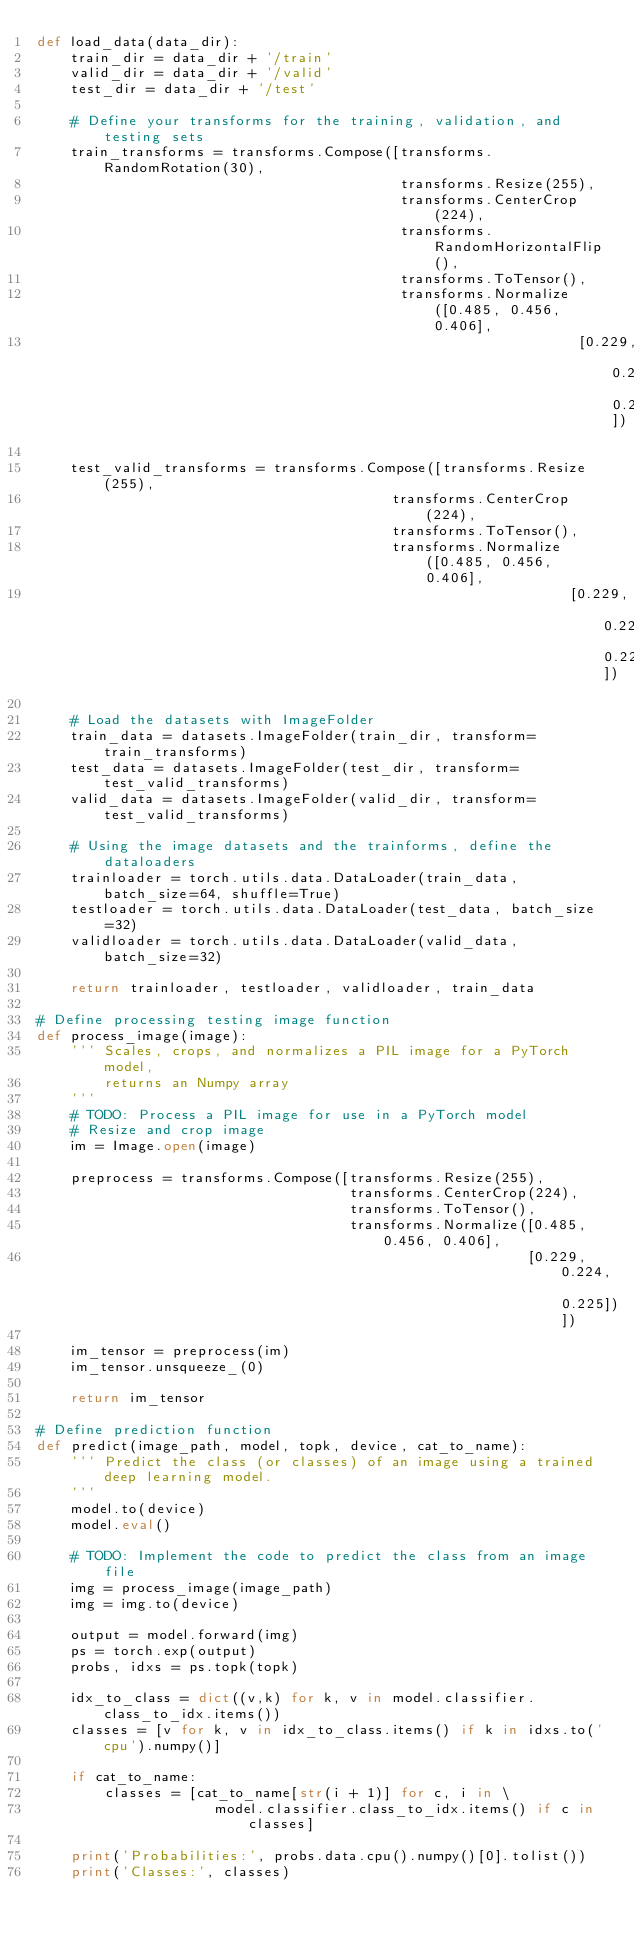<code> <loc_0><loc_0><loc_500><loc_500><_Python_>def load_data(data_dir):
    train_dir = data_dir + '/train'
    valid_dir = data_dir + '/valid'
    test_dir = data_dir + '/test'

    # Define your transforms for the training, validation, and testing sets
    train_transforms = transforms.Compose([transforms.RandomRotation(30),
                                           transforms.Resize(255),
                                           transforms.CenterCrop(224),
                                           transforms.RandomHorizontalFlip(),
                                           transforms.ToTensor(),
                                           transforms.Normalize([0.485, 0.456, 0.406],
                                                                [0.229, 0.224, 0.225])])

    test_valid_transforms = transforms.Compose([transforms.Resize(255), 
                                          transforms.CenterCrop(224),
                                          transforms.ToTensor(),
                                          transforms.Normalize([0.485, 0.456, 0.406],
                                                               [0.229, 0.224, 0.225])])

    # Load the datasets with ImageFolder
    train_data = datasets.ImageFolder(train_dir, transform=train_transforms)
    test_data = datasets.ImageFolder(test_dir, transform=test_valid_transforms)
    valid_data = datasets.ImageFolder(valid_dir, transform=test_valid_transforms)

    # Using the image datasets and the trainforms, define the dataloaders
    trainloader = torch.utils.data.DataLoader(train_data, batch_size=64, shuffle=True)
    testloader = torch.utils.data.DataLoader(test_data, batch_size=32)
    validloader = torch.utils.data.DataLoader(valid_data, batch_size=32)
    
    return trainloader, testloader, validloader, train_data

# Define processing testing image function
def process_image(image):
    ''' Scales, crops, and normalizes a PIL image for a PyTorch model,
        returns an Numpy array
    '''
    # TODO: Process a PIL image for use in a PyTorch model
    # Resize and crop image
    im = Image.open(image)
    
    preprocess = transforms.Compose([transforms.Resize(255), 
                                     transforms.CenterCrop(224),
                                     transforms.ToTensor(),
                                     transforms.Normalize([0.485, 0.456, 0.406],
                                                          [0.229, 0.224, 0.225])])
    
    im_tensor = preprocess(im)
    im_tensor.unsqueeze_(0)
    
    return im_tensor

# Define prediction function 
def predict(image_path, model, topk, device, cat_to_name):
    ''' Predict the class (or classes) of an image using a trained deep learning model.
    '''
    model.to(device)
    model.eval()
    
    # TODO: Implement the code to predict the class from an image file
    img = process_image(image_path)
    img = img.to(device)
    
    output = model.forward(img)
    ps = torch.exp(output)    
    probs, idxs = ps.topk(topk)

    idx_to_class = dict((v,k) for k, v in model.classifier.class_to_idx.items())
    classes = [v for k, v in idx_to_class.items() if k in idxs.to('cpu').numpy()]
    
    if cat_to_name:
        classes = [cat_to_name[str(i + 1)] for c, i in \
                     model.classifier.class_to_idx.items() if c in classes]
        
    print('Probabilities:', probs.data.cpu().numpy()[0].tolist())
    print('Classes:', classes)</code> 